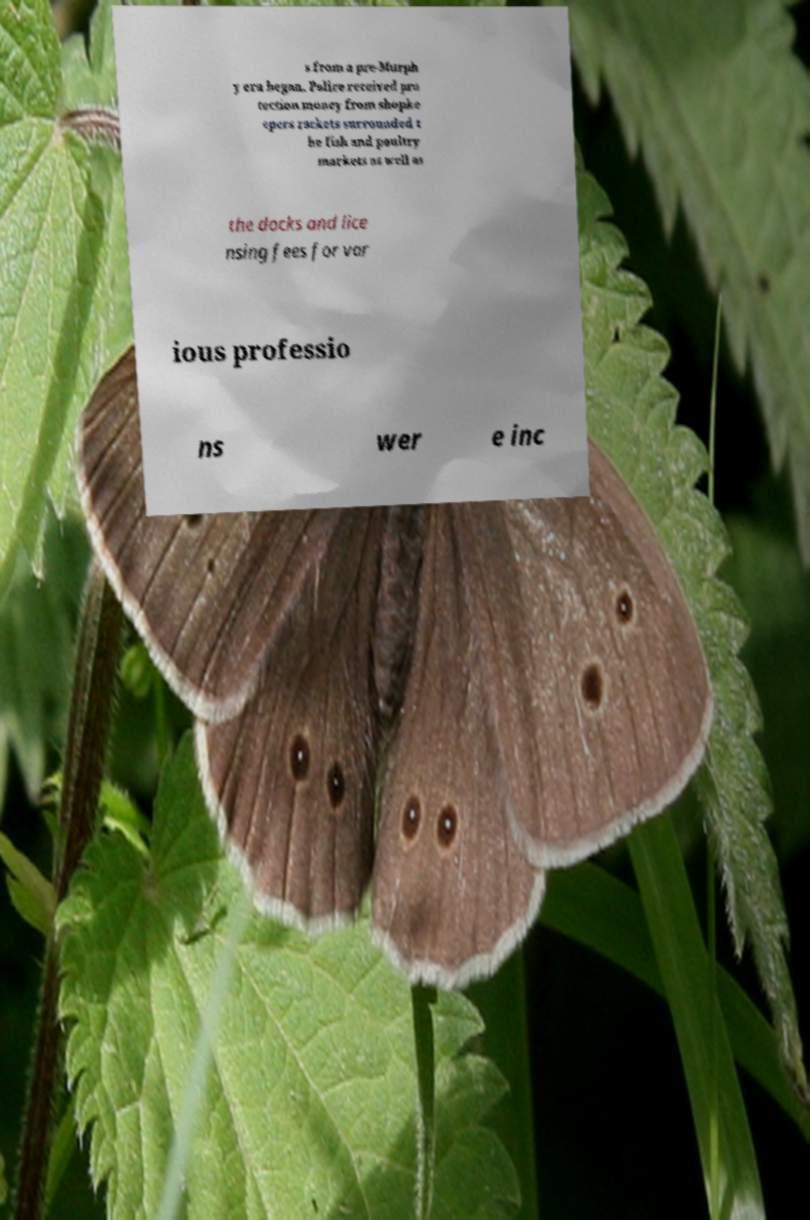Please identify and transcribe the text found in this image. s from a pre-Murph y era began. Police received pro tection money from shopke epers rackets surrounded t he fish and poultry markets as well as the docks and lice nsing fees for var ious professio ns wer e inc 